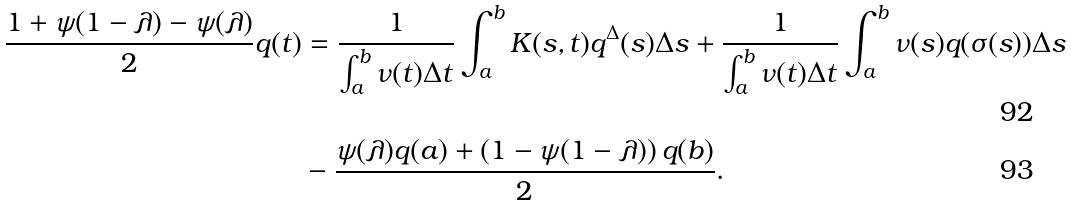Convert formula to latex. <formula><loc_0><loc_0><loc_500><loc_500>\frac { 1 + \psi ( 1 - \lambda ) - \psi ( \lambda ) } { 2 } q ( t ) & = \frac { 1 } { \int _ { a } ^ { b } \nu ( t ) \Delta t } \int _ { a } ^ { b } K ( s , t ) q ^ { \Delta } ( s ) \Delta s + \frac { 1 } { \int _ { a } ^ { b } \nu ( t ) \Delta t } \int _ { a } ^ { b } \nu ( s ) q ( \sigma ( s ) ) \Delta s \\ & - \frac { \psi ( \lambda ) q ( a ) + \left ( 1 - \psi ( 1 - \lambda ) \right ) q ( b ) } { 2 } .</formula> 